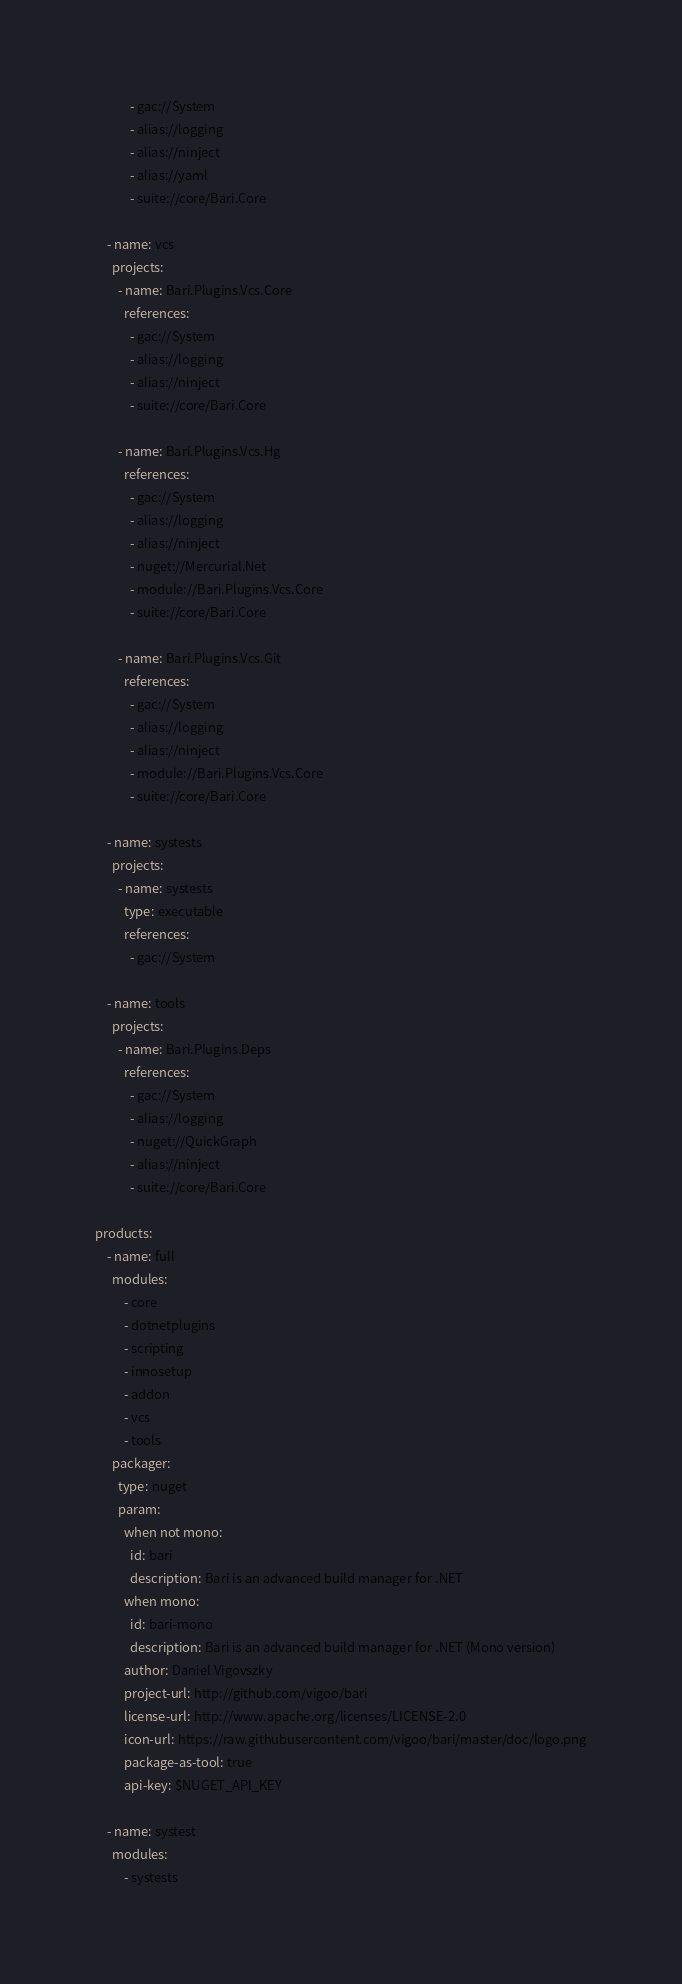Convert code to text. <code><loc_0><loc_0><loc_500><loc_500><_YAML_>            - gac://System
            - alias://logging
            - alias://ninject
            - alias://yaml
            - suite://core/Bari.Core

    - name: vcs
      projects:
        - name: Bari.Plugins.Vcs.Core
          references:
            - gac://System
            - alias://logging
            - alias://ninject
            - suite://core/Bari.Core

        - name: Bari.Plugins.Vcs.Hg
          references:
            - gac://System
            - alias://logging
            - alias://ninject
            - nuget://Mercurial.Net
            - module://Bari.Plugins.Vcs.Core
            - suite://core/Bari.Core

        - name: Bari.Plugins.Vcs.Git
          references:
            - gac://System
            - alias://logging
            - alias://ninject
            - module://Bari.Plugins.Vcs.Core
            - suite://core/Bari.Core

    - name: systests
      projects:
        - name: systests
          type: executable
          references:
            - gac://System
          
    - name: tools
      projects:
        - name: Bari.Plugins.Deps
          references:
            - gac://System
            - alias://logging
            - nuget://QuickGraph
            - alias://ninject
            - suite://core/Bari.Core

products:
    - name: full
      modules:
          - core
          - dotnetplugins
          - scripting
          - innosetup
          - addon
          - vcs
          - tools
      packager:
        type: nuget
        param:
          when not mono:
            id: bari
            description: Bari is an advanced build manager for .NET
          when mono:
            id: bari-mono
            description: Bari is an advanced build manager for .NET (Mono version)
          author: Daniel Vigovszky
          project-url: http://github.com/vigoo/bari
          license-url: http://www.apache.org/licenses/LICENSE-2.0
          icon-url: https://raw.githubusercontent.com/vigoo/bari/master/doc/logo.png
          package-as-tool: true
          api-key: $NUGET_API_KEY

    - name: systest
      modules:
          - systests
</code> 